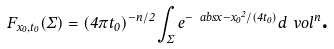Convert formula to latex. <formula><loc_0><loc_0><loc_500><loc_500>F _ { x _ { 0 } , t _ { 0 } } ( \Sigma ) = ( 4 \pi t _ { 0 } ) ^ { - n / 2 } \int _ { \Sigma } e ^ { - \ a b s { x - x _ { 0 } } ^ { 2 } / ( 4 t _ { 0 } ) } d \ v o l ^ { n } \text  .</formula> 